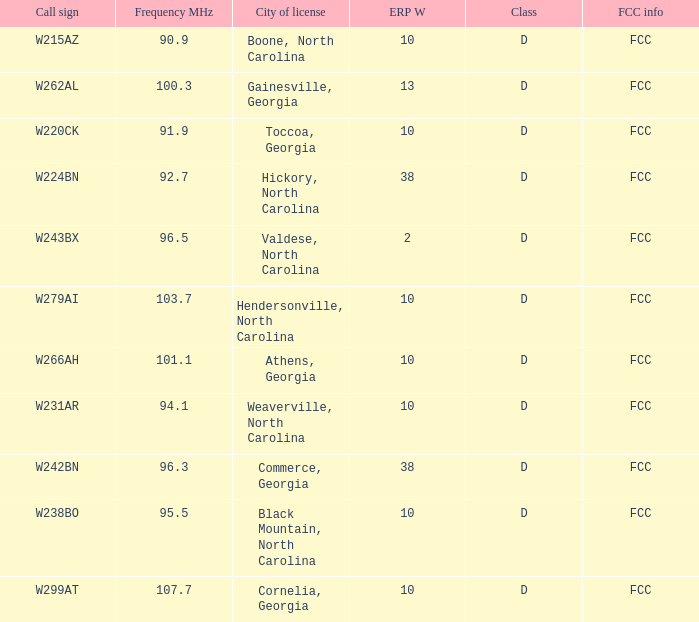Would you mind parsing the complete table? {'header': ['Call sign', 'Frequency MHz', 'City of license', 'ERP W', 'Class', 'FCC info'], 'rows': [['W215AZ', '90.9', 'Boone, North Carolina', '10', 'D', 'FCC'], ['W262AL', '100.3', 'Gainesville, Georgia', '13', 'D', 'FCC'], ['W220CK', '91.9', 'Toccoa, Georgia', '10', 'D', 'FCC'], ['W224BN', '92.7', 'Hickory, North Carolina', '38', 'D', 'FCC'], ['W243BX', '96.5', 'Valdese, North Carolina', '2', 'D', 'FCC'], ['W279AI', '103.7', 'Hendersonville, North Carolina', '10', 'D', 'FCC'], ['W266AH', '101.1', 'Athens, Georgia', '10', 'D', 'FCC'], ['W231AR', '94.1', 'Weaverville, North Carolina', '10', 'D', 'FCC'], ['W242BN', '96.3', 'Commerce, Georgia', '38', 'D', 'FCC'], ['W238BO', '95.5', 'Black Mountain, North Carolina', '10', 'D', 'FCC'], ['W299AT', '107.7', 'Cornelia, Georgia', '10', 'D', 'FCC']]} What class is the city of black mountain, north carolina? D. 